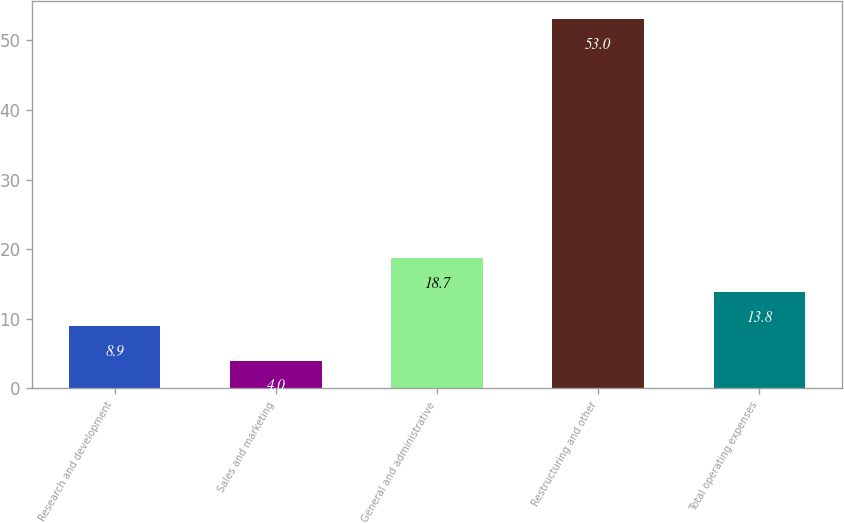<chart> <loc_0><loc_0><loc_500><loc_500><bar_chart><fcel>Research and development<fcel>Sales and marketing<fcel>General and administrative<fcel>Restructuring and other<fcel>Total operating expenses<nl><fcel>8.9<fcel>4<fcel>18.7<fcel>53<fcel>13.8<nl></chart> 